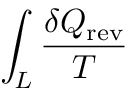Convert formula to latex. <formula><loc_0><loc_0><loc_500><loc_500>\int _ { L } { \frac { \delta Q _ { r e v } } { T } }</formula> 